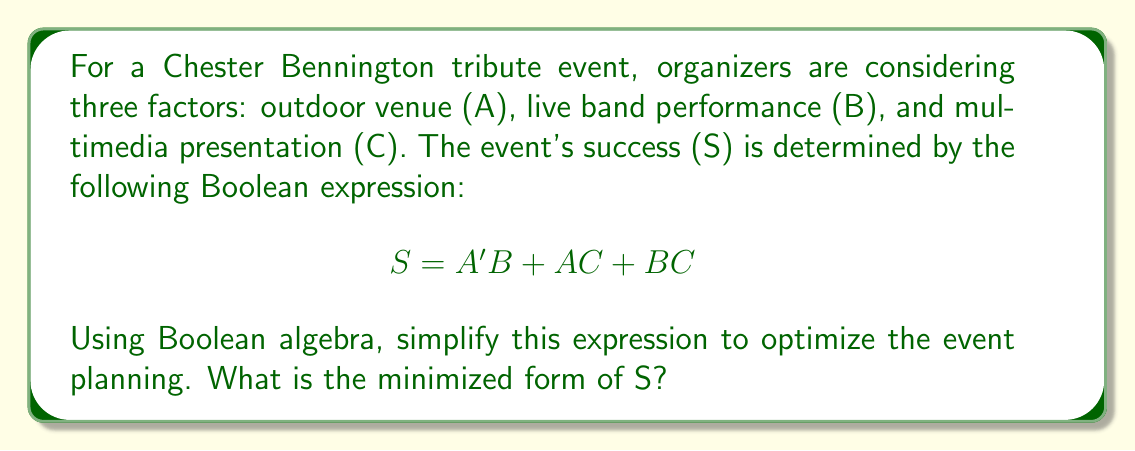Can you solve this math problem? Let's simplify the expression step by step using Boolean algebra laws:

1) Start with the original expression:
   $S = A'B + AC + BC$

2) Apply the distributive law to factor out B:
   $S = A'B + AC + BC$
   $S = B(A' + C) + AC$

3) Apply the complement law: $A + A' = 1$
   $S = B(A' + C) + AC$
   $S = B(A' + C + A) + AC$
   $S = B(1 + C) + AC$

4) Apply the identity law: $1 + X = 1$
   $S = B(1) + AC$
   $S = B + AC$

5) This is the minimized form of S. We can't simplify it further.

The simplified expression $S = B + AC$ means that the event will be successful if:
- There's a live band performance (B), OR
- It's held in an outdoor venue (A) AND there's a multimedia presentation (C)

This optimization suggests that having a live band performance is crucial, while the combination of an outdoor venue and multimedia presentation is an alternative path to success.
Answer: $S = B + AC$ 